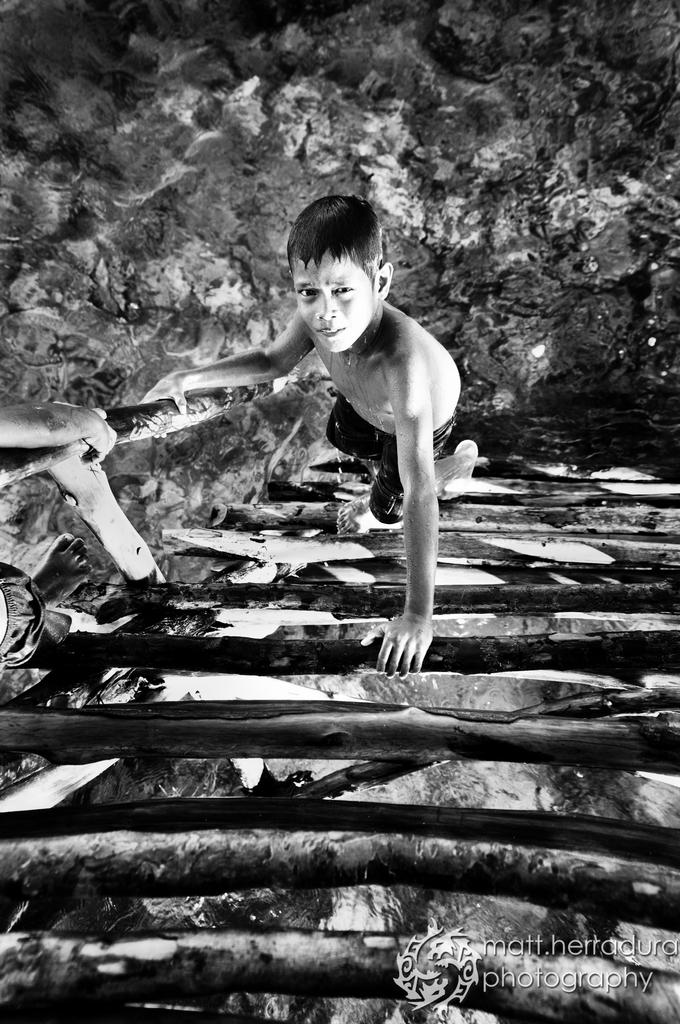What is the main subject of the picture? The main subject of the picture is a boy. What can be said about the color scheme of the picture? The picture is black and white in color. What type of curtain is hanging in the background of the picture? There is no curtain present in the image; it features a boy in a black and white setting. 